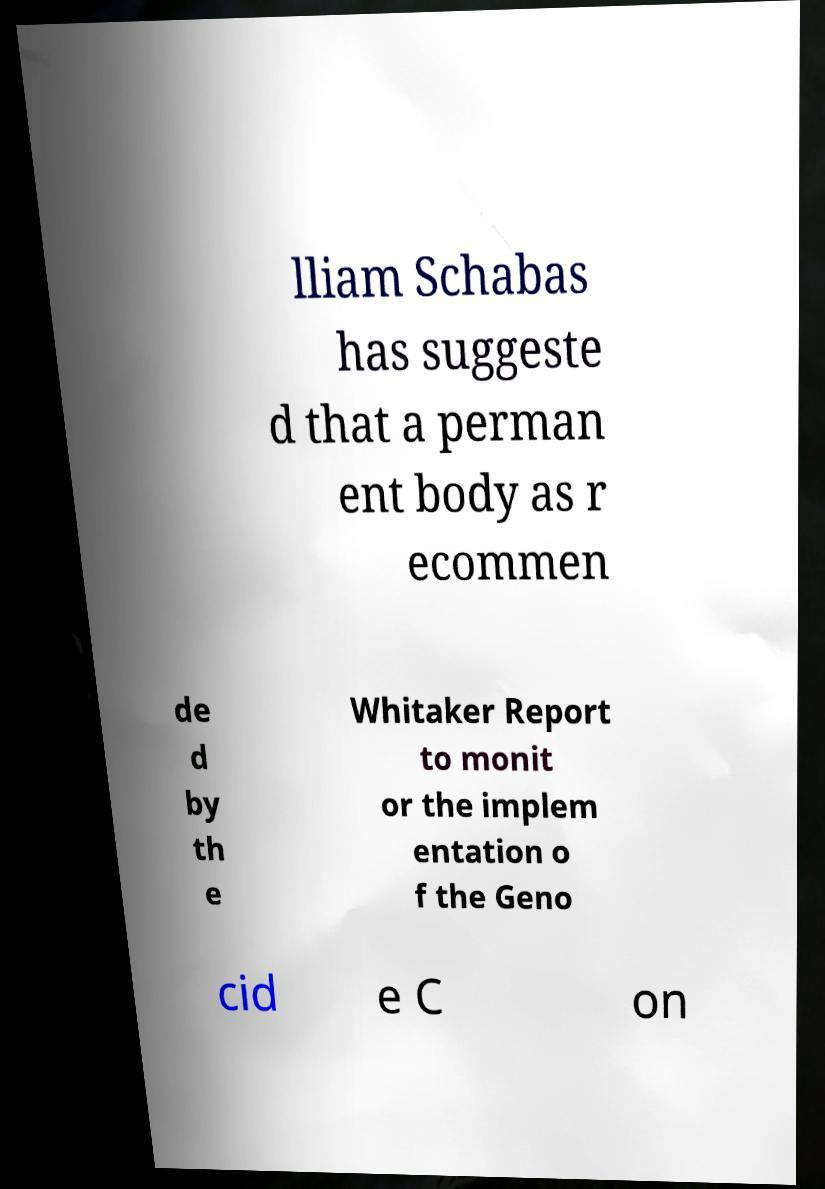Can you accurately transcribe the text from the provided image for me? lliam Schabas has suggeste d that a perman ent body as r ecommen de d by th e Whitaker Report to monit or the implem entation o f the Geno cid e C on 